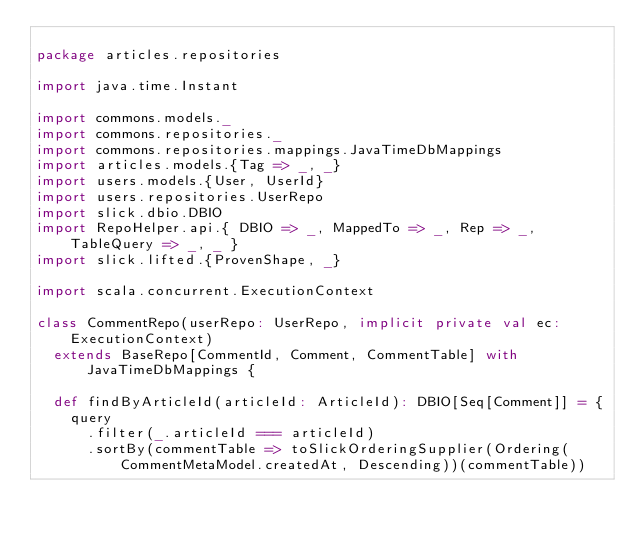<code> <loc_0><loc_0><loc_500><loc_500><_Scala_>
package articles.repositories

import java.time.Instant

import commons.models._
import commons.repositories._
import commons.repositories.mappings.JavaTimeDbMappings
import articles.models.{Tag => _, _}
import users.models.{User, UserId}
import users.repositories.UserRepo
import slick.dbio.DBIO
import RepoHelper.api.{ DBIO => _, MappedTo => _, Rep => _, TableQuery => _, _ }
import slick.lifted.{ProvenShape, _}

import scala.concurrent.ExecutionContext

class CommentRepo(userRepo: UserRepo, implicit private val ec: ExecutionContext)
  extends BaseRepo[CommentId, Comment, CommentTable] with JavaTimeDbMappings {

  def findByArticleId(articleId: ArticleId): DBIO[Seq[Comment]] = {
    query
      .filter(_.articleId === articleId)
      .sortBy(commentTable => toSlickOrderingSupplier(Ordering(CommentMetaModel.createdAt, Descending))(commentTable))</code> 